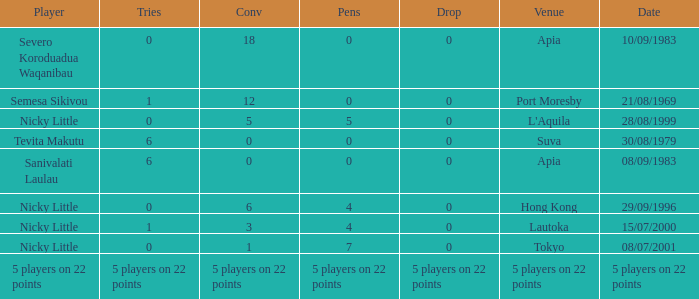How many conversions had 0 pens and 0 tries? 18.0. 